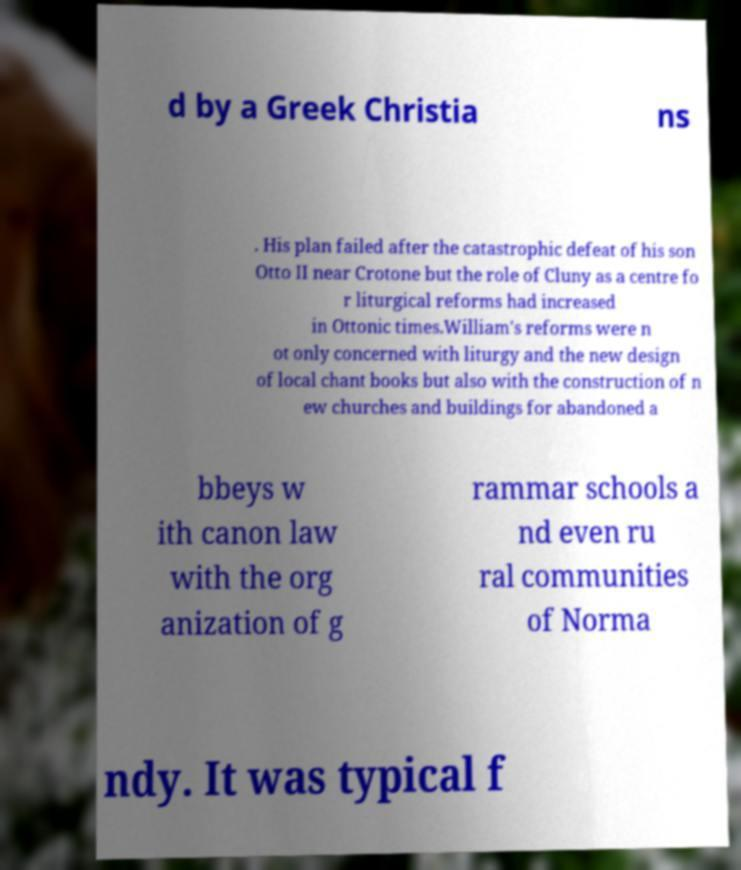Can you read and provide the text displayed in the image?This photo seems to have some interesting text. Can you extract and type it out for me? d by a Greek Christia ns . His plan failed after the catastrophic defeat of his son Otto II near Crotone but the role of Cluny as a centre fo r liturgical reforms had increased in Ottonic times.William's reforms were n ot only concerned with liturgy and the new design of local chant books but also with the construction of n ew churches and buildings for abandoned a bbeys w ith canon law with the org anization of g rammar schools a nd even ru ral communities of Norma ndy. It was typical f 